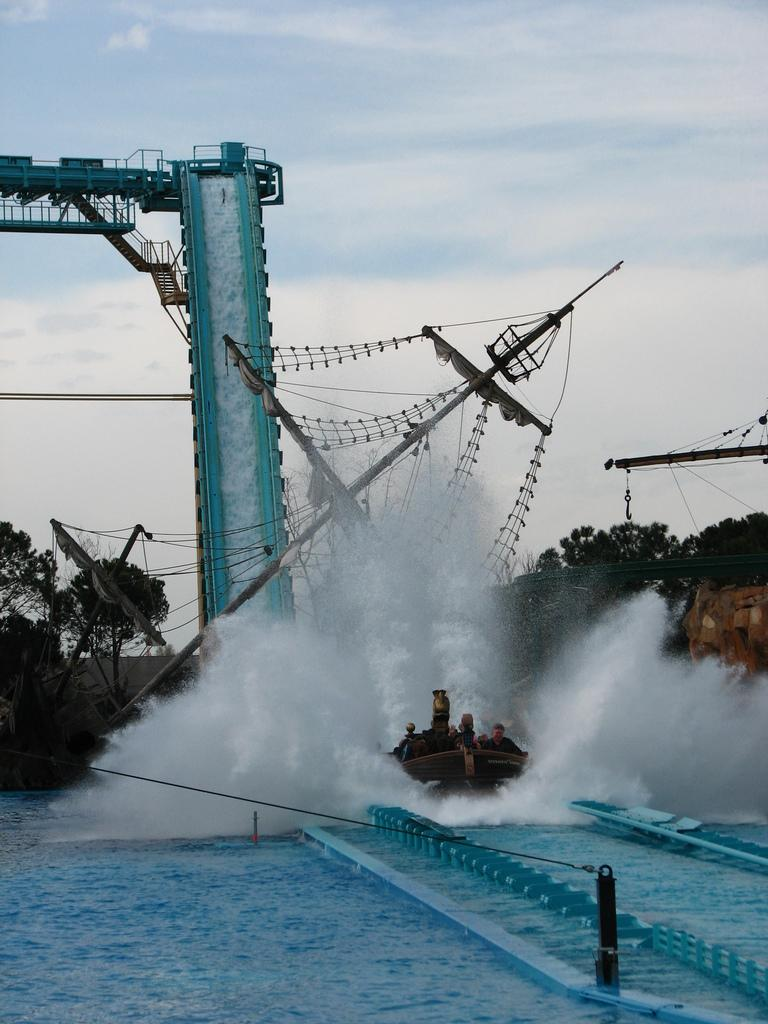What can be seen in the background of the image? In the background of the image, there is water, trees, and clouds in the sky. Can you describe the natural elements present in the background? The background features water, trees, and clouds in the sky. What type of weather might be suggested by the presence of clouds in the image? The presence of clouds in the sky suggests that the weather might be partly cloudy or overcast. Can you see a snail crawling on the fork in the image? There is no fork or snail present in the image. What type of current is flowing through the water in the image? There is no current visible in the water in the image. 